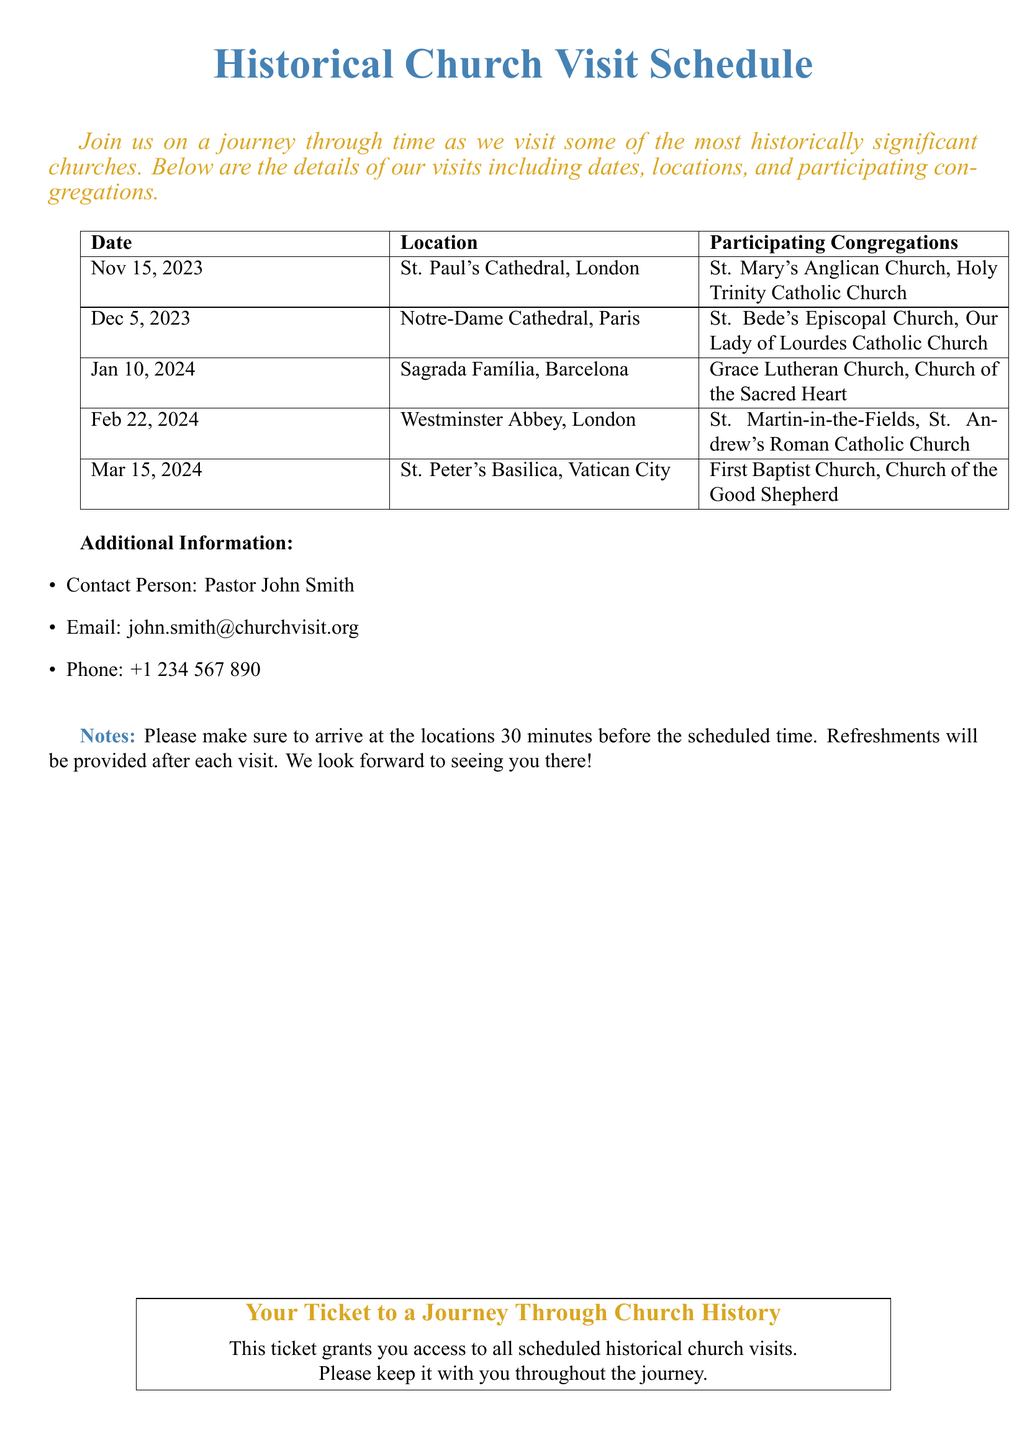what is the date of the visit to St. Paul's Cathedral? The visit to St. Paul's Cathedral is scheduled for November 15, 2023.
Answer: November 15, 2023 which church is located in Paris? The document lists Notre-Dame Cathedral as the church located in Paris.
Answer: Notre-Dame Cathedral who should you contact for more information? The contact person's name provided in the document is Pastor John Smith.
Answer: Pastor John Smith how many congregations are participating in the visit to Sagrada Família? The document states that there are two congregations participating in the visit to Sagrada Família.
Answer: two what will be provided after each visit? The document mentions that refreshments will be provided after each visit.
Answer: refreshments which two congregations are participating in the visit to St. Peter's Basilica? The document lists First Baptist Church and Church of the Good Shepherd as the participating congregations for the visit to St. Peter's Basilica.
Answer: First Baptist Church, Church of the Good Shepherd how long before the scheduled time should attendees arrive? The document specifies that attendees should arrive 30 minutes before the scheduled time.
Answer: 30 minutes what is the main purpose of the ticket? The ticket grants access to all scheduled historical church visits, as stated in the document.
Answer: access to all scheduled visits 